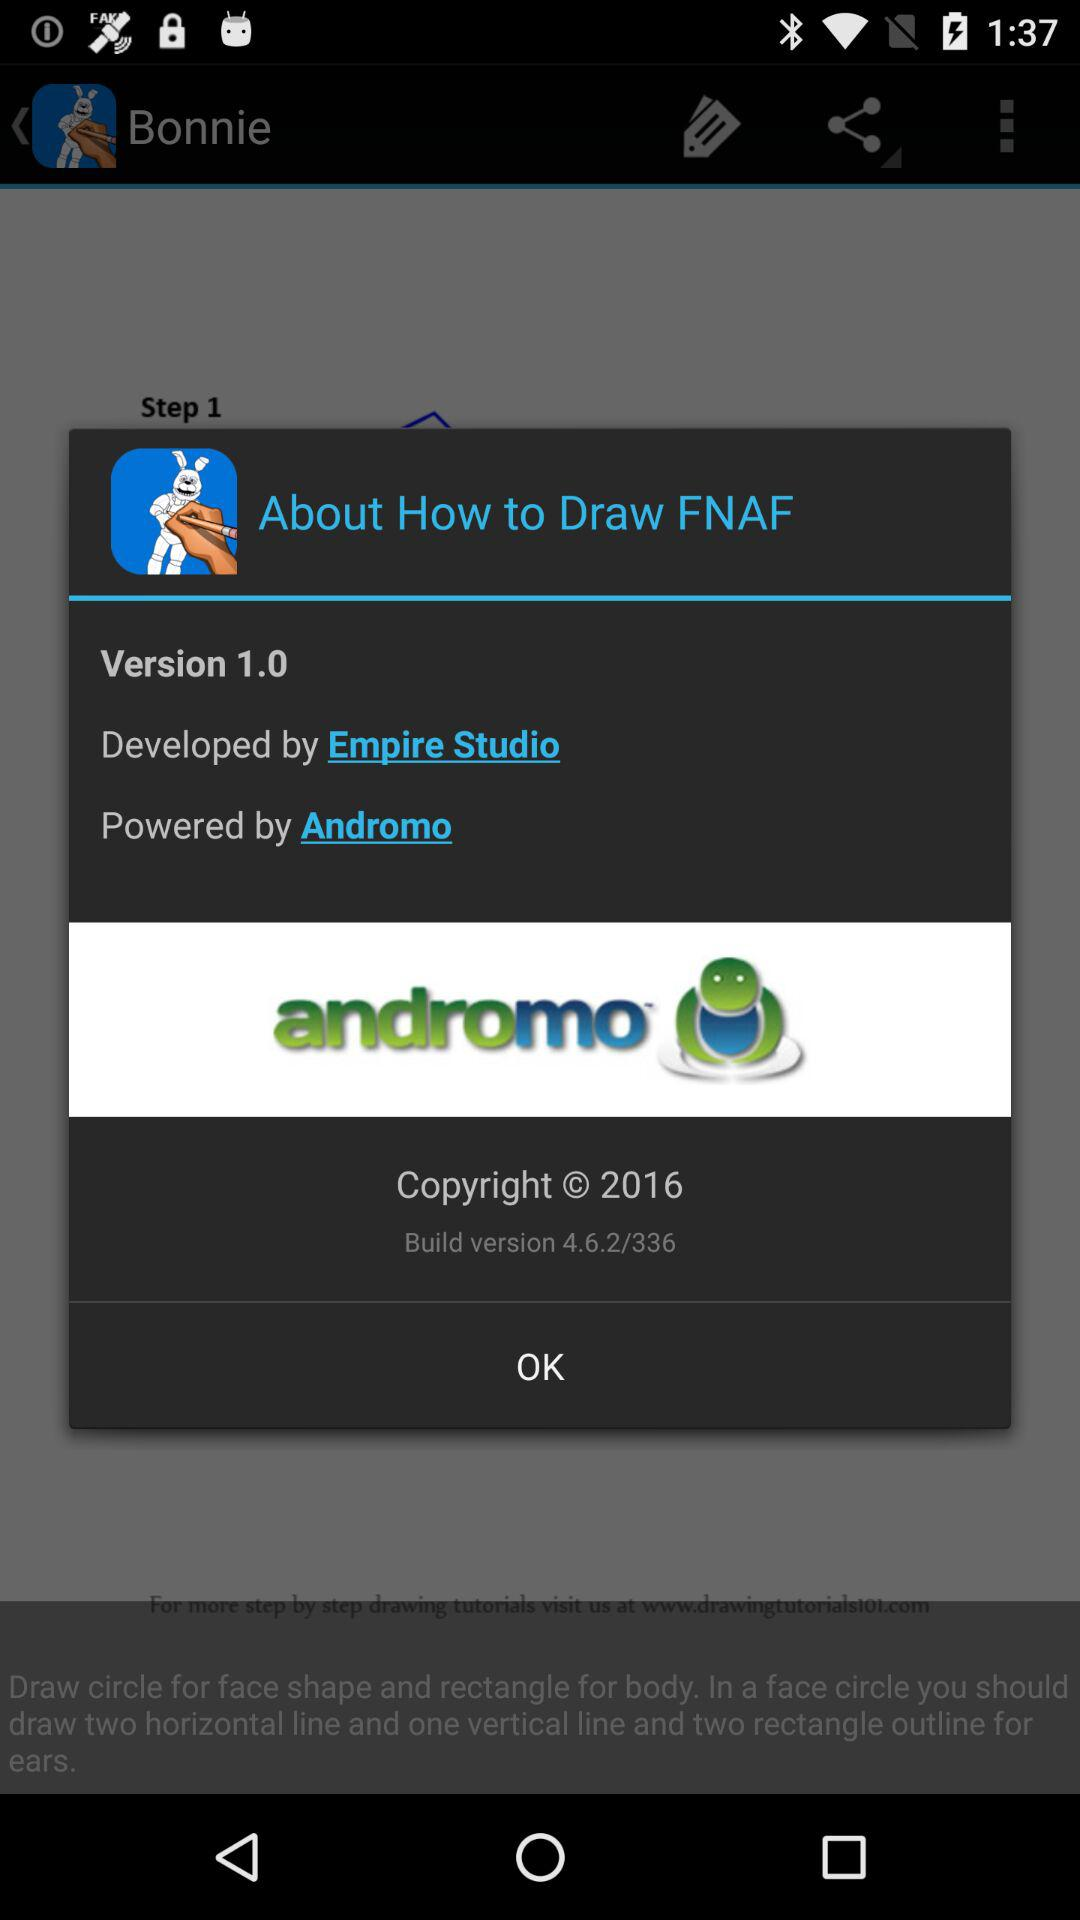What is the build version? The build version is 4.6.2/336. 